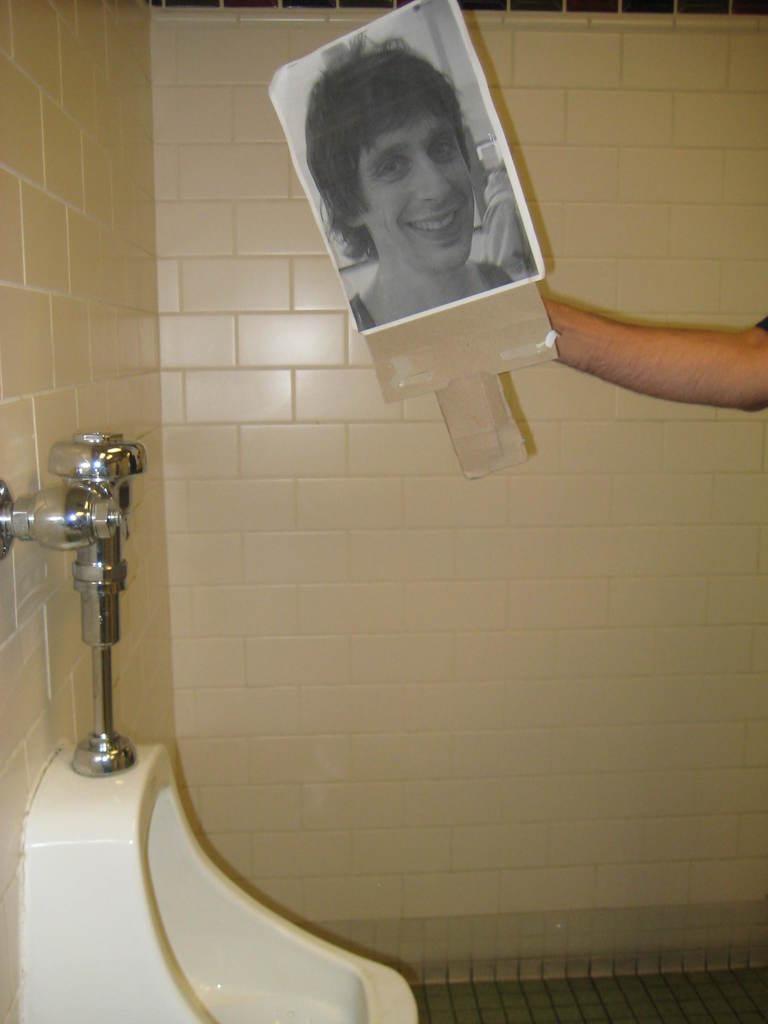In one or two sentences, can you explain what this image depicts? In this image I can see a person hand holding a board. In the board I can see a person face. In front I can see a toilet in white color and I can also see a tap attached to the wall and the wall is in cream color. 